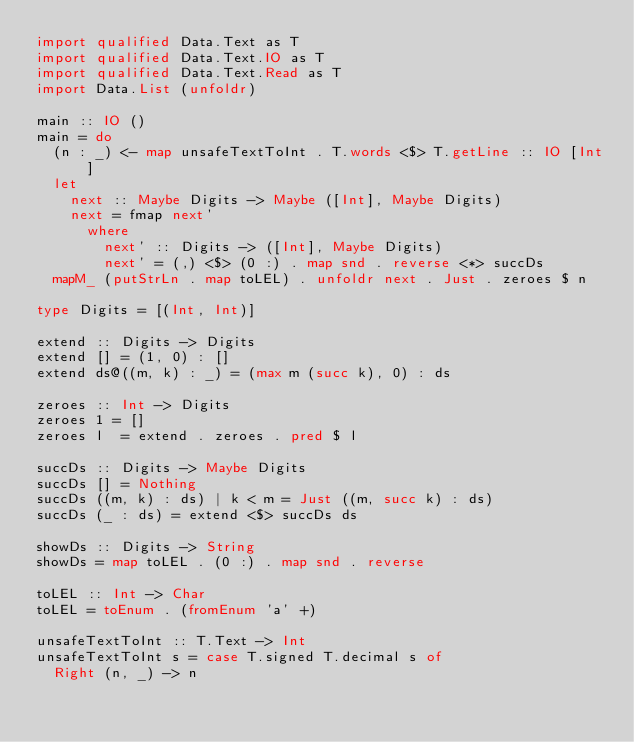<code> <loc_0><loc_0><loc_500><loc_500><_Haskell_>import qualified Data.Text as T
import qualified Data.Text.IO as T
import qualified Data.Text.Read as T
import Data.List (unfoldr)

main :: IO ()
main = do
  (n : _) <- map unsafeTextToInt . T.words <$> T.getLine :: IO [Int]
  let
    next :: Maybe Digits -> Maybe ([Int], Maybe Digits)
    next = fmap next'
      where
        next' :: Digits -> ([Int], Maybe Digits)
        next' = (,) <$> (0 :) . map snd . reverse <*> succDs
  mapM_ (putStrLn . map toLEL) . unfoldr next . Just . zeroes $ n

type Digits = [(Int, Int)]

extend :: Digits -> Digits
extend [] = (1, 0) : []
extend ds@((m, k) : _) = (max m (succ k), 0) : ds

zeroes :: Int -> Digits
zeroes 1 = []
zeroes l  = extend . zeroes . pred $ l

succDs :: Digits -> Maybe Digits
succDs [] = Nothing
succDs ((m, k) : ds) | k < m = Just ((m, succ k) : ds)
succDs (_ : ds) = extend <$> succDs ds

showDs :: Digits -> String
showDs = map toLEL . (0 :) . map snd . reverse

toLEL :: Int -> Char
toLEL = toEnum . (fromEnum 'a' +)

unsafeTextToInt :: T.Text -> Int
unsafeTextToInt s = case T.signed T.decimal s of
  Right (n, _) -> n
</code> 